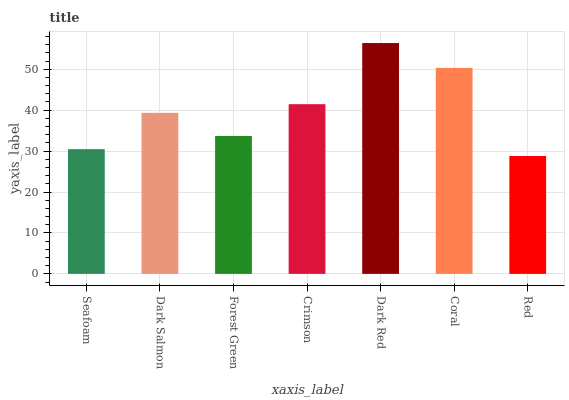Is Red the minimum?
Answer yes or no. Yes. Is Dark Red the maximum?
Answer yes or no. Yes. Is Dark Salmon the minimum?
Answer yes or no. No. Is Dark Salmon the maximum?
Answer yes or no. No. Is Dark Salmon greater than Seafoam?
Answer yes or no. Yes. Is Seafoam less than Dark Salmon?
Answer yes or no. Yes. Is Seafoam greater than Dark Salmon?
Answer yes or no. No. Is Dark Salmon less than Seafoam?
Answer yes or no. No. Is Dark Salmon the high median?
Answer yes or no. Yes. Is Dark Salmon the low median?
Answer yes or no. Yes. Is Seafoam the high median?
Answer yes or no. No. Is Seafoam the low median?
Answer yes or no. No. 